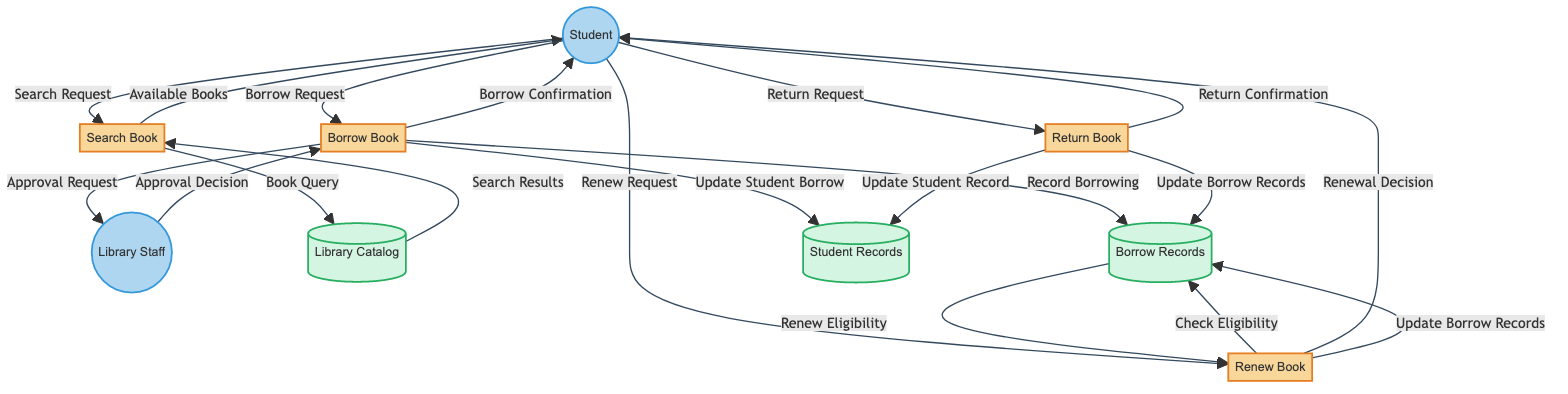What is the first process in the diagram? The first process is labeled as "Search Book," which can be found at the top of the process list in the diagram.
Answer: Search Book How many external entities are present? The diagram indicates there are two external entities: "Student" and "Library Staff." Thus, by counting them, we find there are two external entities.
Answer: 2 What is the data flow from "Return Book" to "Student"? The data flow from "Return Book" to "Student" is labeled as "Return Confirmation," as shown by the connection labeled with this title in the diagram.
Answer: Return Confirmation Which process follows the "Borrow Book" process? The diagram does not have any process following "Borrow Book." It ends with the flow of "Borrow Confirmation" to the "Student." Therefore, there is no subsequent process after it.
Answer: None In which data store is the "Record Borrowing" made? The "Record Borrowing" is made in the "Borrow Records" data store, evident from the flow going from "Borrow Book" to "Borrow Records" labeled as "Record Borrowing."
Answer: Borrow Records What data flow connects "Student" to "Search Book"? The data flow connecting "Student" to "Search Book" is labeled as "Search Request," indicated within the diagram.
Answer: Search Request Which entity makes the "Approval Decision"? The "Approval Decision" is made by the "Library Staff," as indicated by the flow from "Library Staff" to "Borrow Book" labeled "Approval Decision."
Answer: Library Staff What is the last step in the renewal process? The last step in the renewal process is "Update Borrow Records," which is the final action taken by the "Renew Book" process indicated by the flow to "Borrow Records."
Answer: Update Borrow Records 